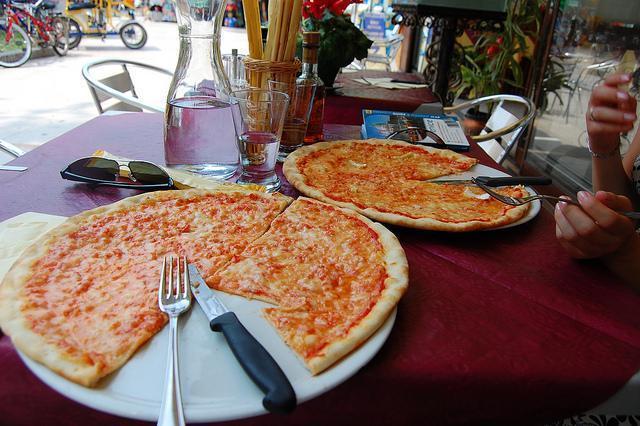What color is the vase in the middle of the table surrounded by pizzas?
Indicate the correct response and explain using: 'Answer: answer
Rationale: rationale.'
Options: Black, red, clear, white. Answer: clear.
Rationale: There is clear water in a glass pitcher which glass is see thru and able to see what is inside it. 